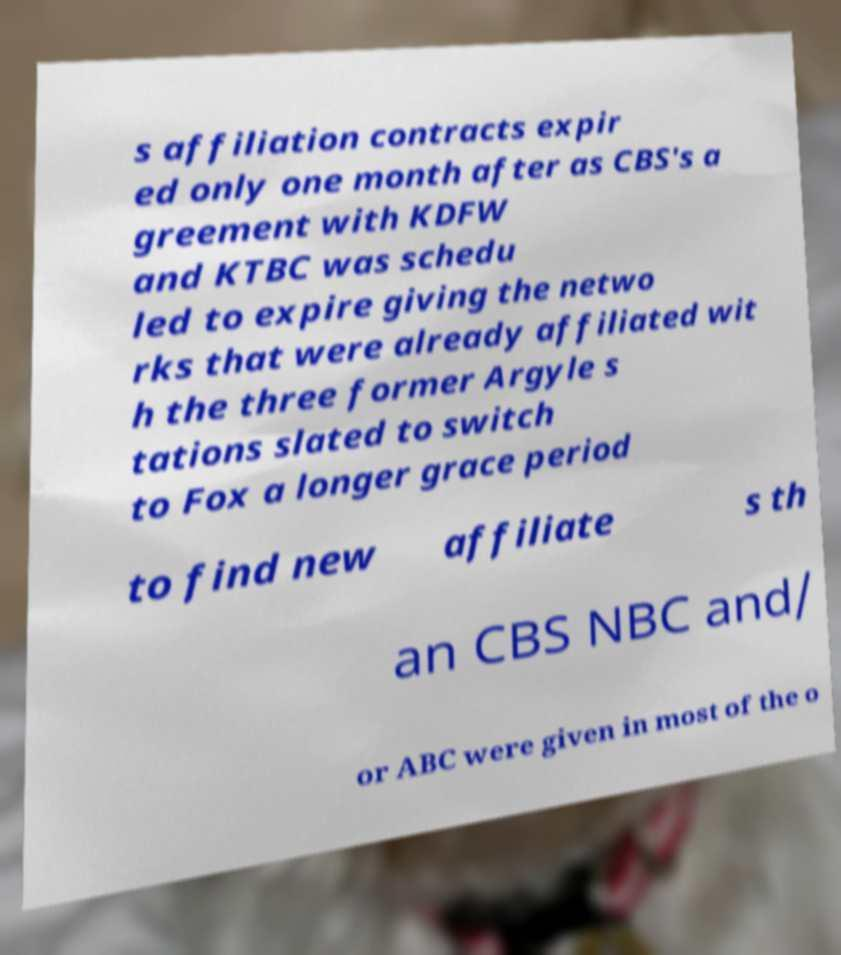I need the written content from this picture converted into text. Can you do that? s affiliation contracts expir ed only one month after as CBS's a greement with KDFW and KTBC was schedu led to expire giving the netwo rks that were already affiliated wit h the three former Argyle s tations slated to switch to Fox a longer grace period to find new affiliate s th an CBS NBC and/ or ABC were given in most of the o 